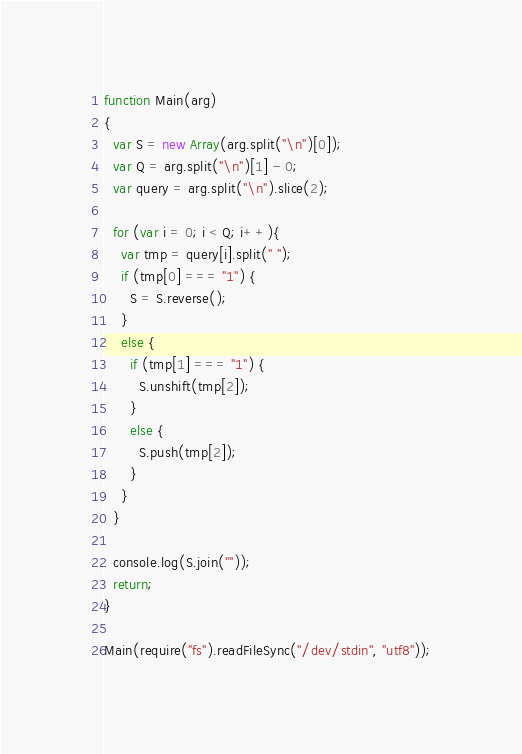Convert code to text. <code><loc_0><loc_0><loc_500><loc_500><_JavaScript_>
function Main(arg)
{
  var S = new Array(arg.split("\n")[0]);
  var Q = arg.split("\n")[1] - 0;
  var query = arg.split("\n").slice(2);

  for (var i = 0; i < Q; i++){
    var tmp = query[i].split(" ");
    if (tmp[0] === "1") {
      S = S.reverse();
    }
    else {
      if (tmp[1] === "1") {
        S.unshift(tmp[2]);
      }
      else {
        S.push(tmp[2]);
      }
    }
  }

  console.log(S.join(""));
  return;
}

Main(require("fs").readFileSync("/dev/stdin", "utf8"));</code> 